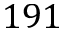Convert formula to latex. <formula><loc_0><loc_0><loc_500><loc_500>1 9 1</formula> 